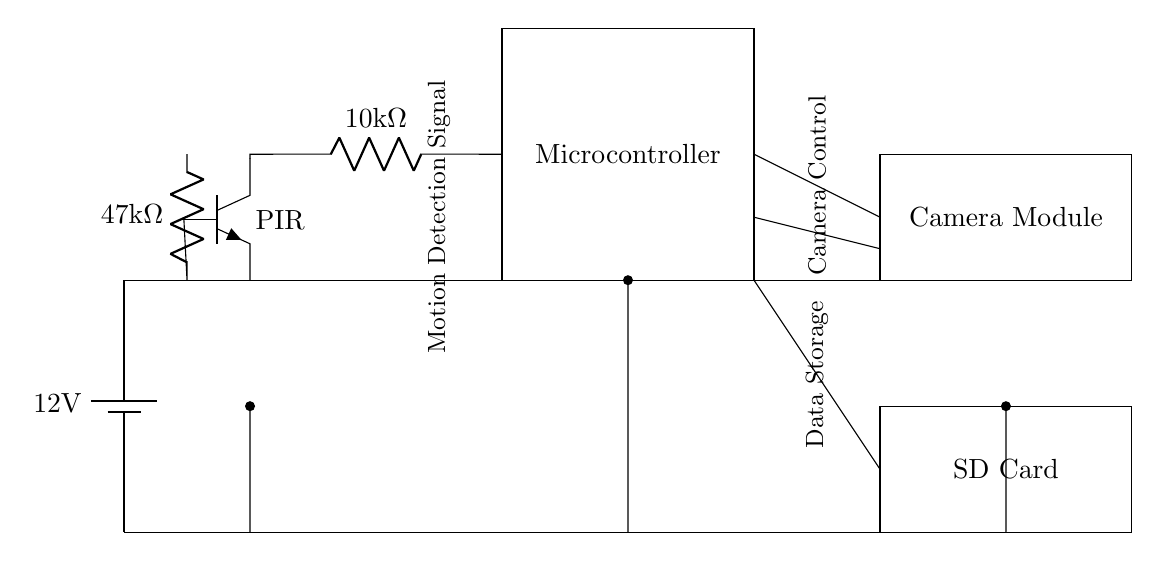What is the voltage of the power supply? The voltage is explicitly labeled as 12 volts in the circuit diagram near the battery symbol.
Answer: 12 volts What is the resistance value of the first resistor? The resistance of the first resistor is indicated as 10 kilo-ohms in the circuit diagram attached to it.
Answer: 10 kilo-ohms What component detects motion in this circuit? The component responsible for detecting motion is labeled as PIR, which stands for Passive Infrared Sensor.
Answer: PIR How many components are connected to the microcontroller? Three components are connected to the microcontroller: the motion sensor, the camera module, and the data storage (SD card). Counting these connections leads to the answer.
Answer: Three What is the function of the SD card in this circuit? The SD card serves as data storage for the recordings made by the camera module, storing the captured video or images. This function is inferred from its position and label in the diagram.
Answer: Data storage Which resistor has the highest resistance value? The resistor with the higher resistance value is labeled as 47 kilo-ohms. Comparing the values of the resistors shows that this is the highest value present.
Answer: 47 kilo-ohms What signal is indicated to control the camera? The signal controlling the camera is referred to as Camera Control, which connects from the microcontroller to the camera module, as labeled in the diagram.
Answer: Camera Control 